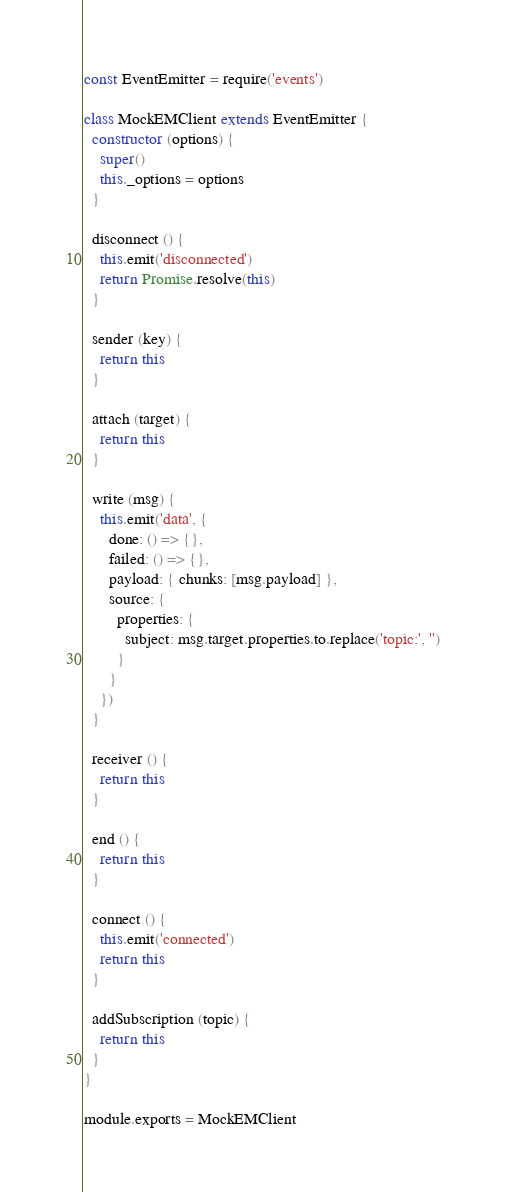Convert code to text. <code><loc_0><loc_0><loc_500><loc_500><_JavaScript_>const EventEmitter = require('events')

class MockEMClient extends EventEmitter {
  constructor (options) {
    super()
    this._options = options
  }

  disconnect () {
    this.emit('disconnected')
    return Promise.resolve(this)
  }

  sender (key) {
    return this
  }

  attach (target) {
    return this
  }

  write (msg) {
    this.emit('data', {
      done: () => {},
      failed: () => {},
      payload: { chunks: [msg.payload] },
      source: {
        properties: {
          subject: msg.target.properties.to.replace('topic:', '')
        }
      }
    })
  }

  receiver () {
    return this
  }

  end () {
    return this
  }

  connect () {
    this.emit('connected')
    return this
  }

  addSubscription (topic) {
    return this
  }
}

module.exports = MockEMClient
</code> 